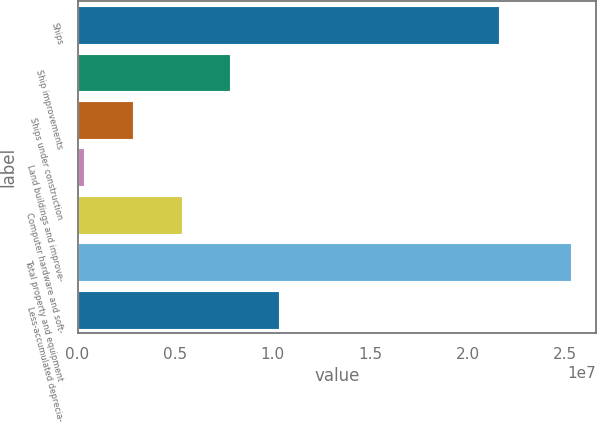Convert chart to OTSL. <chart><loc_0><loc_0><loc_500><loc_500><bar_chart><fcel>Ships<fcel>Ship improvements<fcel>Ships under construction<fcel>Land buildings and improve-<fcel>Computer hardware and soft-<fcel>Total property and equipment<fcel>Less-accumulated deprecia-<nl><fcel>2.16203e+07<fcel>7.8422e+06<fcel>2.84696e+06<fcel>349339<fcel>5.34458e+06<fcel>2.53256e+07<fcel>1.03398e+07<nl></chart> 